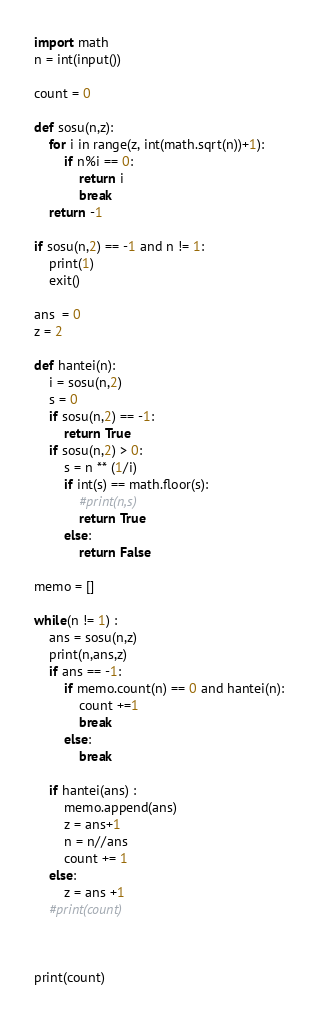Convert code to text. <code><loc_0><loc_0><loc_500><loc_500><_Python_>import math
n = int(input())

count = 0

def sosu(n,z):
    for i in range(z, int(math.sqrt(n))+1):
        if n%i == 0:
            return i
            break
    return -1

if sosu(n,2) == -1 and n != 1:
    print(1)
    exit()

ans  = 0
z = 2

def hantei(n):
    i = sosu(n,2)
    s = 0
    if sosu(n,2) == -1:
        return True
    if sosu(n,2) > 0:
        s = n ** (1/i)
        if int(s) == math.floor(s):
            #print(n,s)
            return True
        else:
            return False

memo = []

while(n != 1) :
    ans = sosu(n,z)
    print(n,ans,z)
    if ans == -1:
        if memo.count(n) == 0 and hantei(n):
            count +=1
            break
        else:
            break

    if hantei(ans) :
        memo.append(ans)
        z = ans+1
        n = n//ans
        count += 1
    else:
        z = ans +1
    #print(count)



print(count)
</code> 